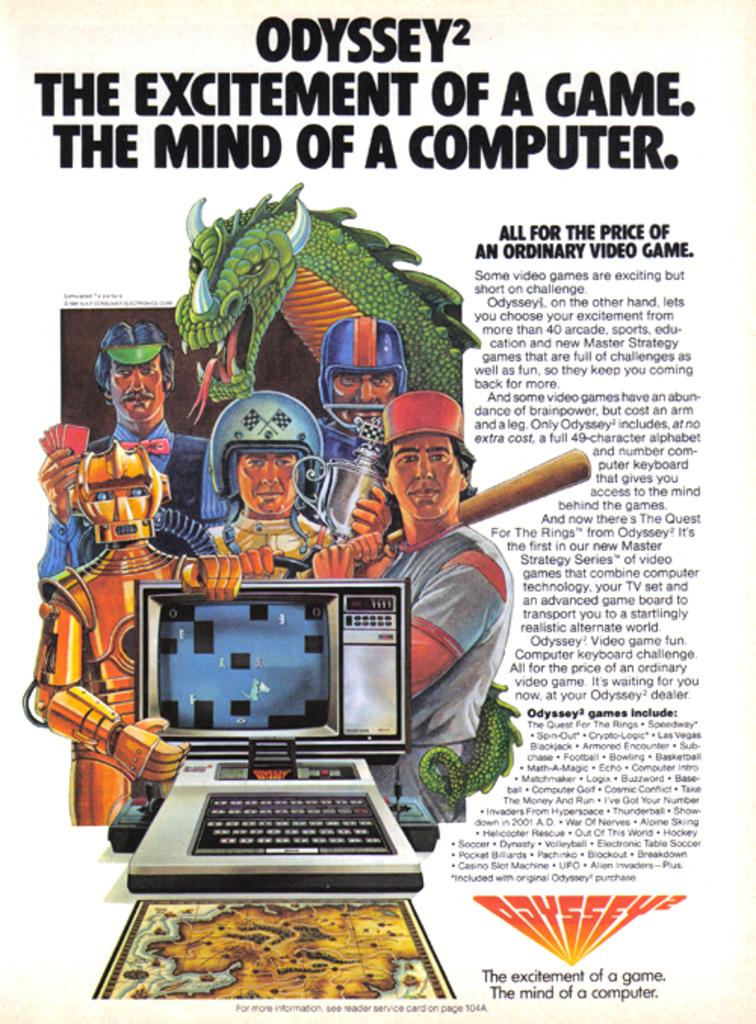Provide a one-sentence caption for the provided image. An advertisement for an Odyssey video game system. 